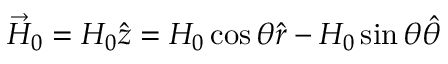<formula> <loc_0><loc_0><loc_500><loc_500>{ \vec { H } } _ { 0 } = H _ { 0 } { \hat { z } } = H _ { 0 } \cos \theta { \hat { r } } - H _ { 0 } \sin \theta { \hat { \theta } }</formula> 